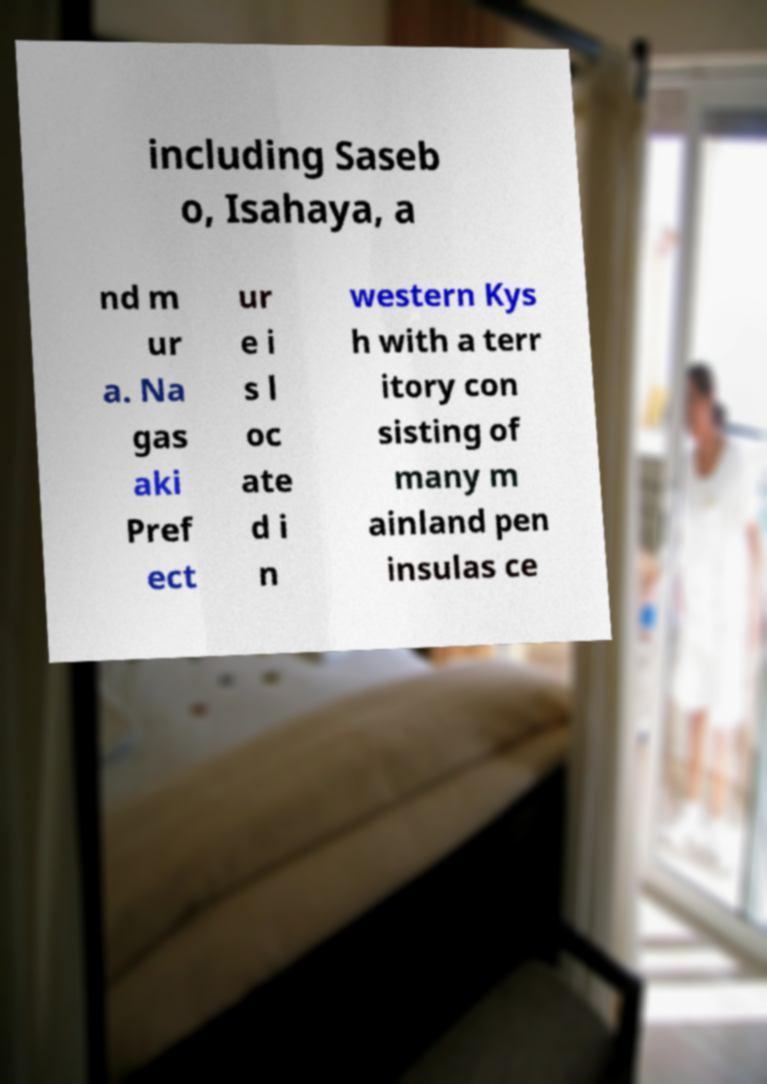For documentation purposes, I need the text within this image transcribed. Could you provide that? including Saseb o, Isahaya, a nd m ur a. Na gas aki Pref ect ur e i s l oc ate d i n western Kys h with a terr itory con sisting of many m ainland pen insulas ce 